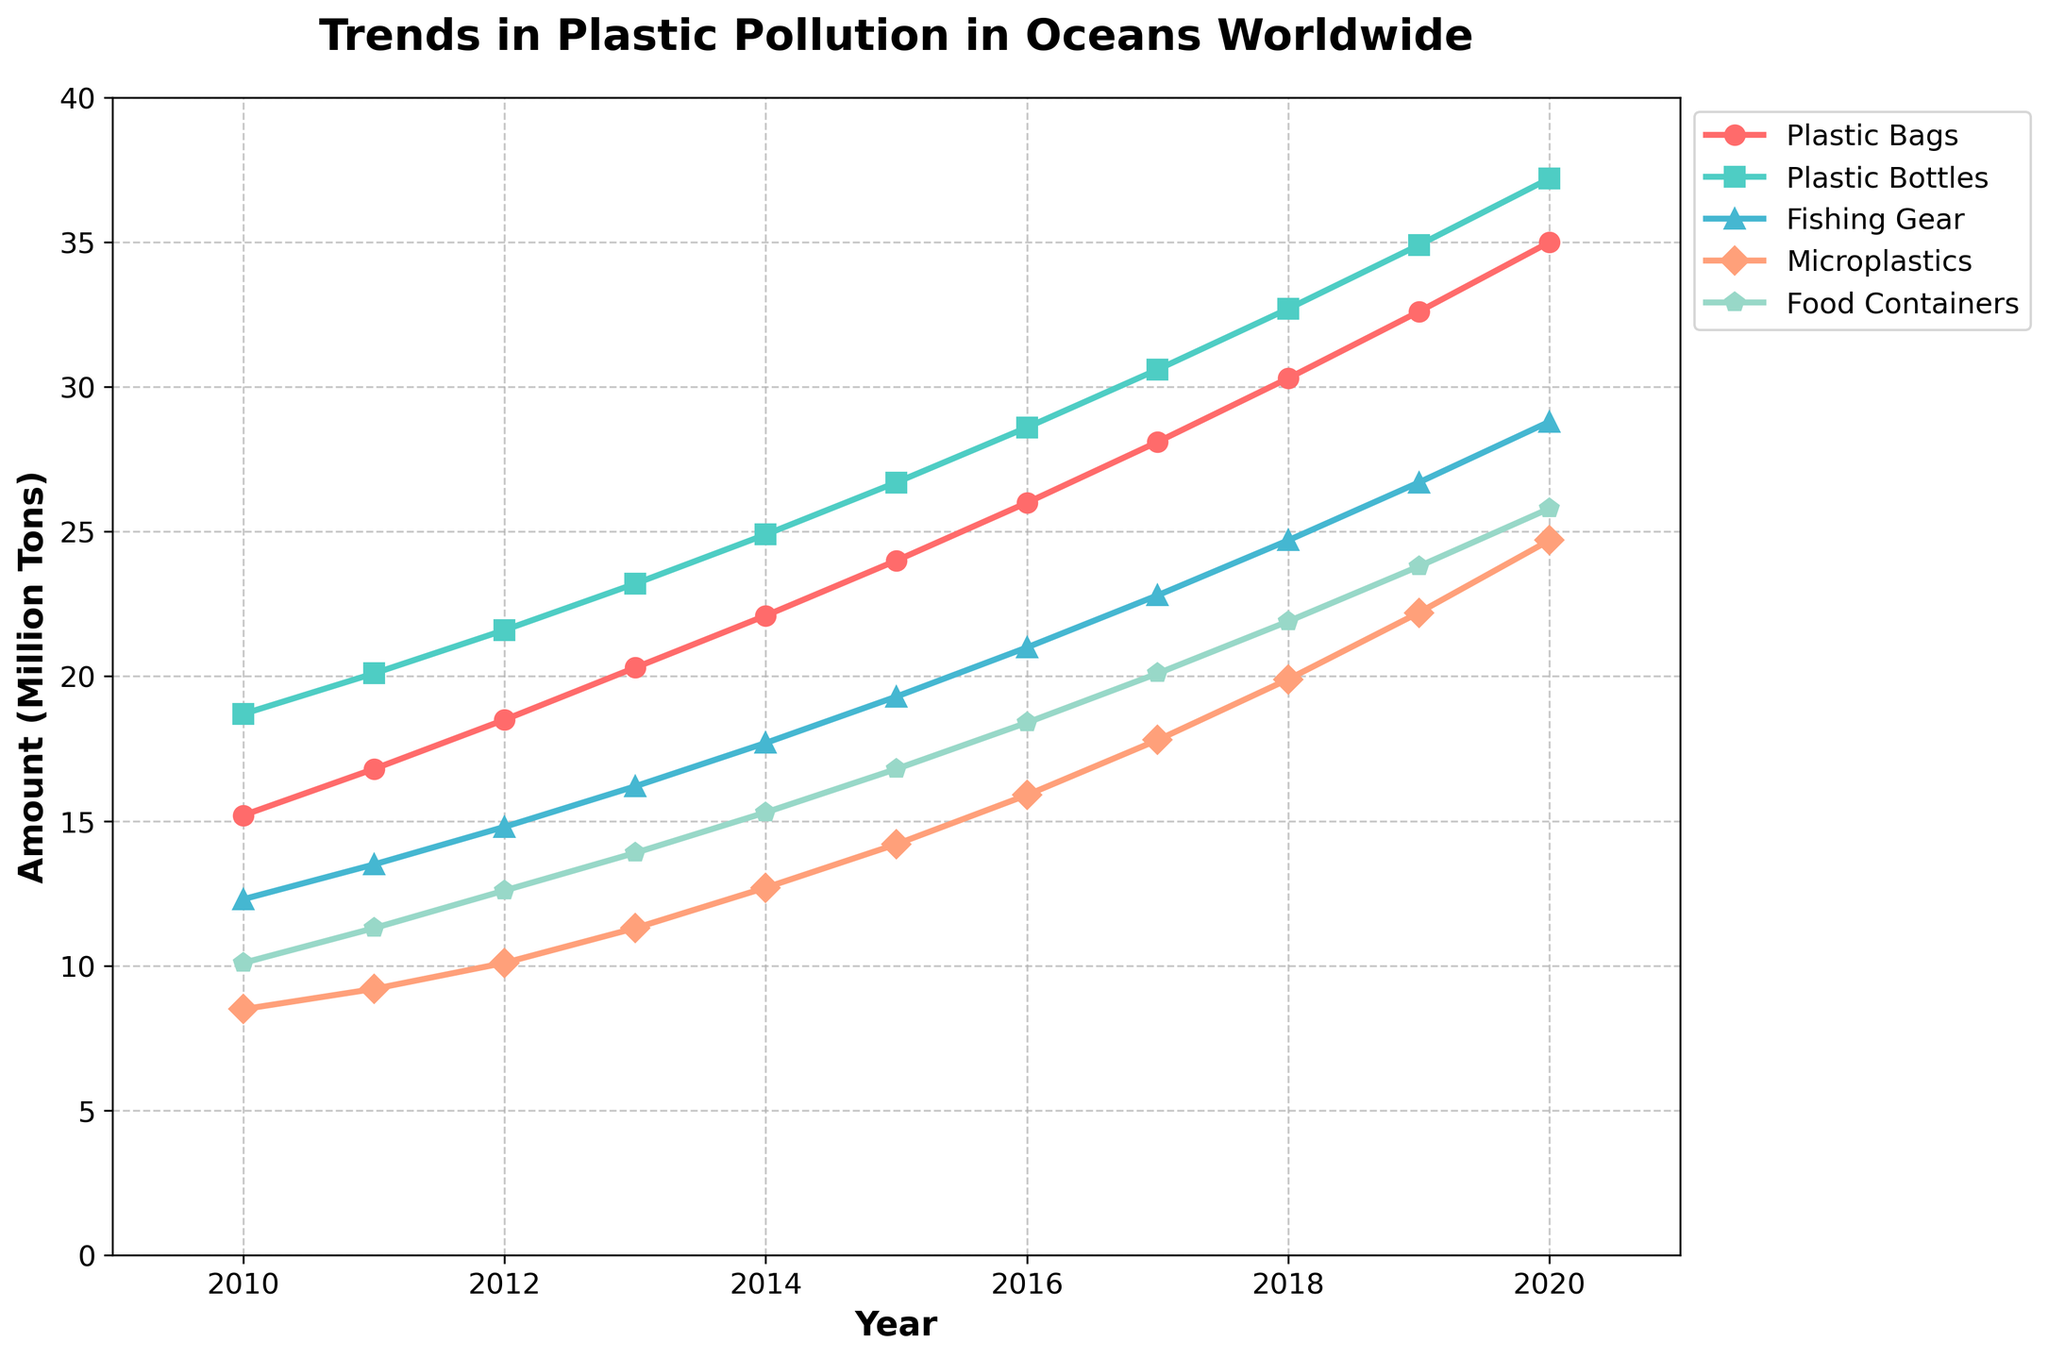What's the trend in the amount of fishing gear found in oceans from 2010 to 2020? From the line chart, observe the trend of the "Fishing Gear" line, which starts at 12.3 million tons in 2010 and steadily increases to 28.8 million tons in 2020.
Answer: It's an increasing trend In what year did plastic bags surpass 20 million tons in oceans? Locate the "Plastic Bags" line and find the first year where it exceeds 20 million tons. The value first exceeds 20 million tons in 2013 (20.3 million tons).
Answer: 2013 By how much did the amount of food containers increase from 2015 to 2020? Find the values for food containers in 2015 (16.8 million tons) and 2020 (25.8 million tons), then calculate the difference: 25.8 - 16.8 = 9.
Answer: 9 million tons Which type of plastic waste had the highest increase in the period from 2010 to 2020? Observe the starting and ending points for each type of plastic waste. Calculate the differences: Plastic Bags (35.0-15.2), Plastic Bottles (37.2-18.7), Fishing Gear (28.8-12.3), Microplastics (24.7-8.5), Food Containers (25.8-10.1). The highest difference is for Plastic Bottles (37.2 - 18.7 = 18.5).
Answer: Plastic Bottles In 2015, which type of plastic waste was the second-most prevalent in the oceans? Look at the 2015 data points and arrange them in descending order: Plastic Bottles (26.7), Plastic Bags (24.0), Fishing Gear (19.3), Food Containers (16.8), Microplastics (14.2). The second-highest value is for Plastic Bags (24.0 million tons).
Answer: Plastic Bags How much greater was the amount of microplastics in 2020 compared to 2010? Find the values in 2010 and 2020 for microplastics: 2020 (24.7 million tons) and 2010 (8.5 million tons). Subtract the 2010 value from the 2020 value: 24.7 - 8.5 = 16.2.
Answer: 16.2 million tons What is the average annual increase in plastic bottles from 2010 to 2020? First, find the total increase: 37.2 million tons in 2020 minus 18.7 million tons in 2010, which equals 18.5 million tons. Divide by the number of years (2020-2010 = 10 years): 18.5 / 10 = 1.85 million tons per year.
Answer: 1.85 million tons Which type of plastic waste stayed below 20 million tons the longest? Compare the figures for all types. Microplastics remain below 20 million tons until 2018. The other types of plastic waste cross the 20 million threshold earlier.
Answer: Microplastics What year did plastic bottles have approximately the same value as plastic bags in 2011? Find the value of plastic bags in 2011 (16.8 million tons). Plastic Bottles reach a similar value between 2011 and 2012 but are closer in 2011 already at 17.8 million tons.
Answer: 2011 